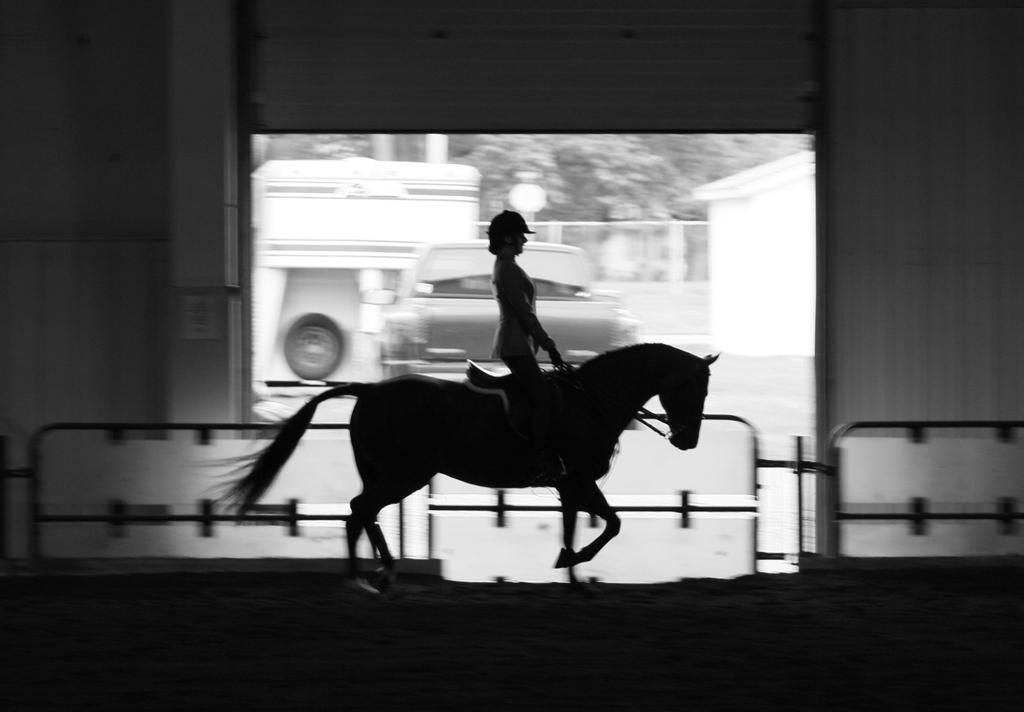Who is the main subject in the image? There is a woman in the image. What is the woman doing in the image? The woman is riding a horse. What other objects or structures can be seen in the image? There is a car and a barricade in the image. What can be seen in the background of the image? There are trees in the background of the image. How many apples are being used to build the town in the image? There is no town or apples present in the image. Is the woman in the image under attack by any creatures? There is no indication of an attack or any creatures in the image. 